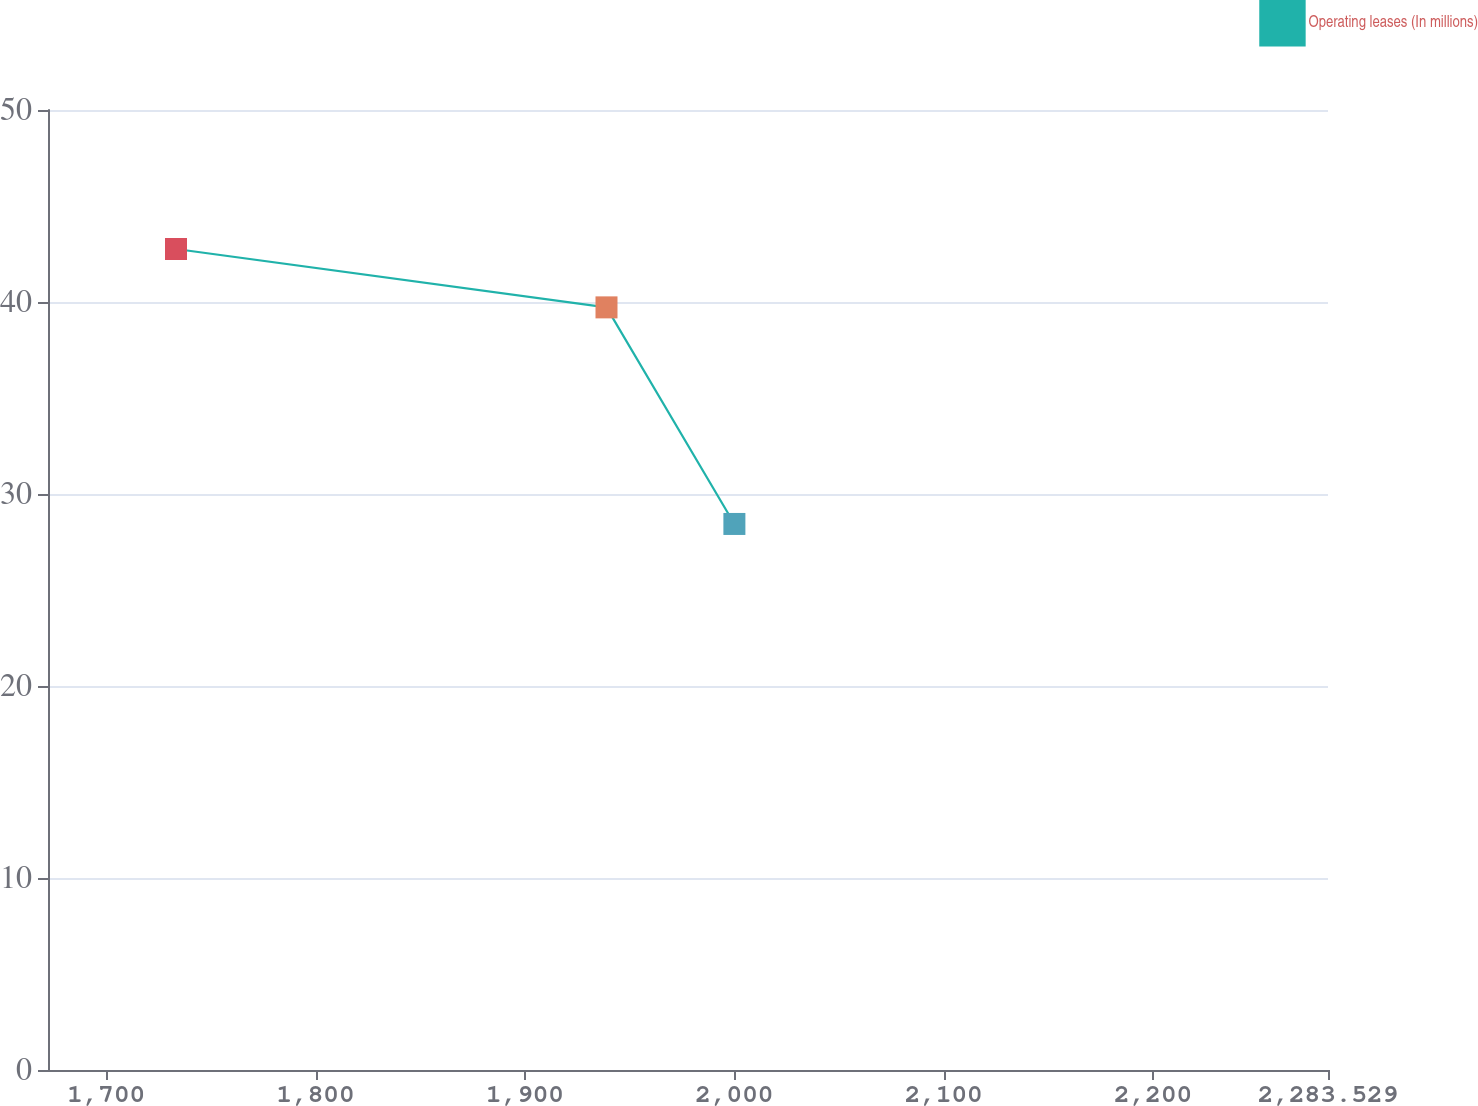Convert chart. <chart><loc_0><loc_0><loc_500><loc_500><line_chart><ecel><fcel>Operating leases (In millions)<nl><fcel>1733.35<fcel>42.76<nl><fcel>1938.95<fcel>39.72<nl><fcel>2000.03<fcel>28.44<nl><fcel>2283.58<fcel>34.41<nl><fcel>2344.66<fcel>32.98<nl></chart> 